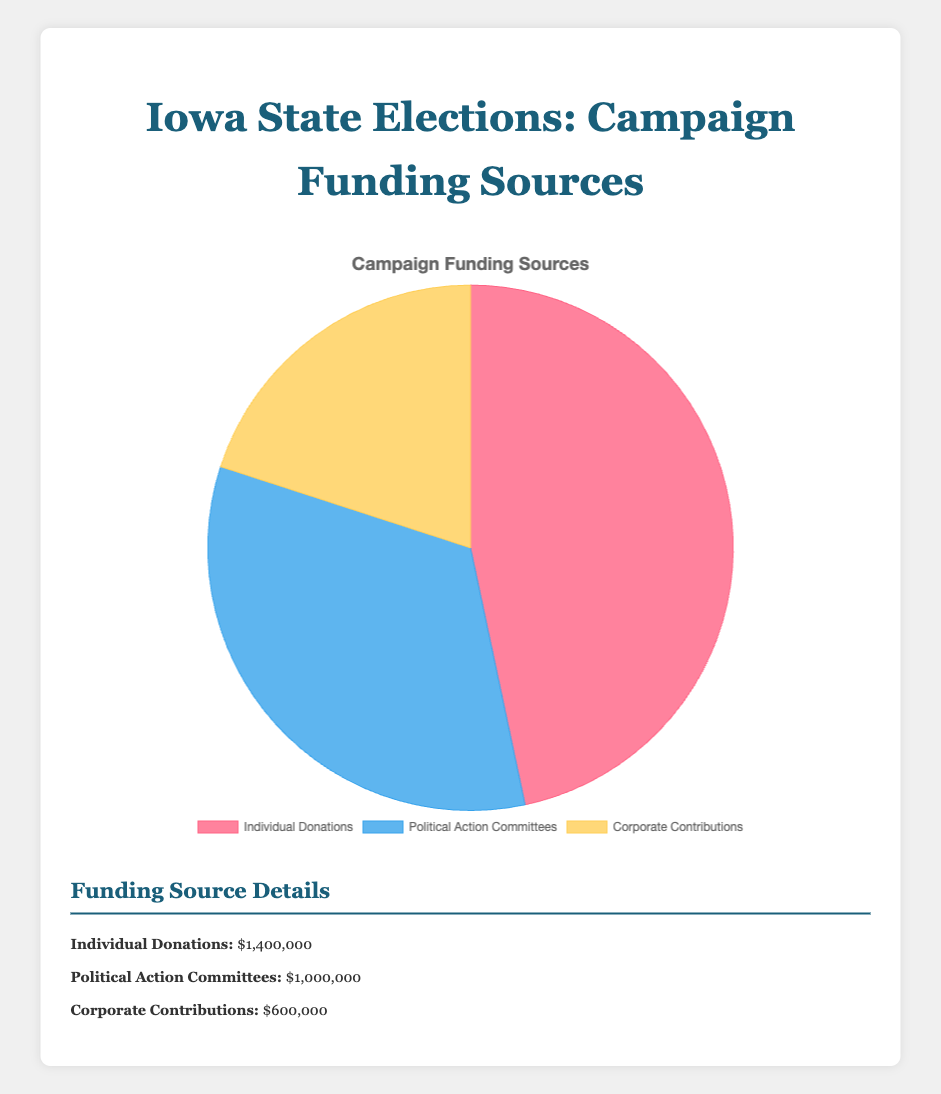What's the total amount of campaign funding presented in the pie chart? To find the total, sum the amounts from all sources: Individual Donations ($1,400,000) + Political Action Committees ($1,000,000) + Corporate Contributions ($600,000).
Answer: $3,000,000 Which source contributes the most to campaign funding? From the chart, Individual Donations have the highest total amount of $1,400,000 compared to the other sources.
Answer: Individual Donations What is the percentage of funding from Corporate Contributions? Divide the Corporate Contributions amount ($600,000) by the total funding amount and multiply by 100: ($600,000 / $3,000,000) * 100.
Answer: 20% How much more funding do Individual Donations contribute compared to Political Action Committees? Subtract the amount from Political Action Committees from Individual Donations: $1,400,000 - $1,000,000.
Answer: $400,000 Are Political Action Committees or Corporate Contributions a smaller part of the pie chart? Comparing $1,000,000 from Political Action Committees and $600,000 from Corporate Contributions, the smaller amount ($600,000) is from Corporate Contributions.
Answer: Corporate Contributions What percentage of total funding comes from Individual Donations and Political Action Committees combined? Sum the amounts from both sources and then divide by the total funding amount, multiply by 100: (($1,400,000 + $1,000,000) / $3,000,000) * 100.
Answer: 80% What fraction of the total funding is from Political Action Committees? Divide the amount from Political Action Committees by the total amount: $1,000,000 / $3,000,000.
Answer: 1/3 If you were to visually compare the colors representing the funding sources, which color corresponds to the smallest segment? The colors are red for Individual Donations, blue for Political Action Committees, and yellow for Corporate Contributions. The smallest segment (Corporate Contributions) is yellow.
Answer: yellow How does the financial support from Corporate Contributions compare to that from Individual Donations? Corporate Contributions ($600,000) are less than half of Individual Donations ($1,400,000).
Answer: Less than half Is the amount contributed by Political Action Committees closer to the amount from Individual Donations or Corporate Contributions? Political Action Committees' funding amount ($1,000,000) is closer to Individual Donations ($1,400,000) than Corporate Contributions ($600,000).
Answer: Individual Donations 